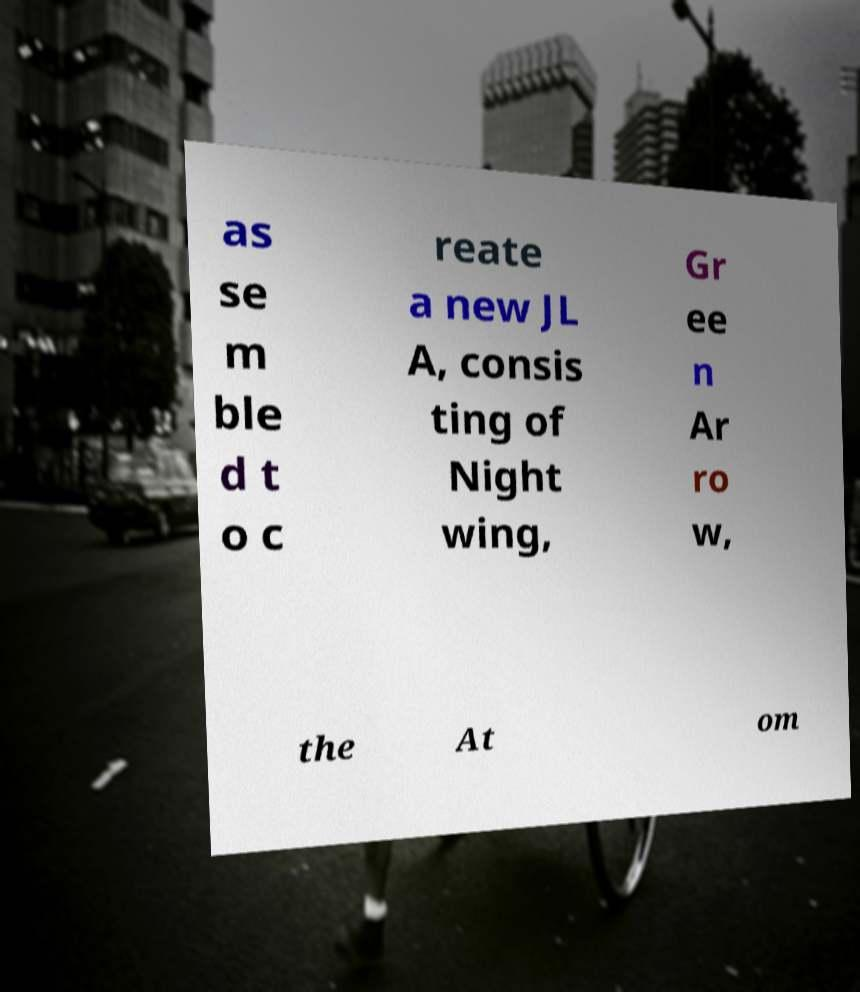I need the written content from this picture converted into text. Can you do that? as se m ble d t o c reate a new JL A, consis ting of Night wing, Gr ee n Ar ro w, the At om 